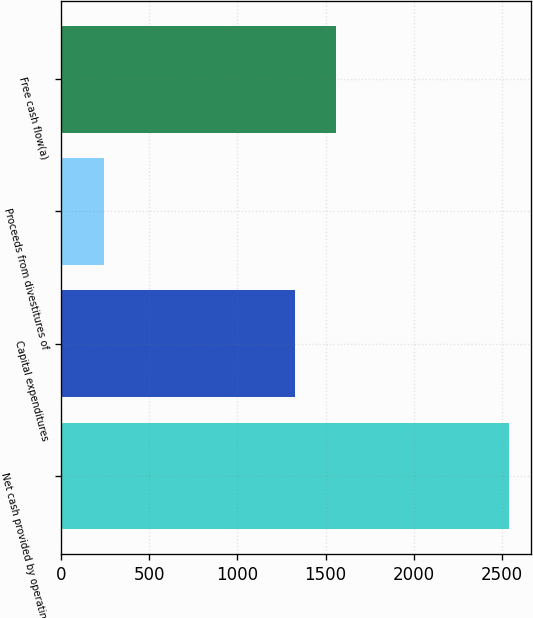Convert chart to OTSL. <chart><loc_0><loc_0><loc_500><loc_500><bar_chart><fcel>Net cash provided by operating<fcel>Capital expenditures<fcel>Proceeds from divestitures of<fcel>Free cash flow(a)<nl><fcel>2540<fcel>1329<fcel>240<fcel>1559<nl></chart> 